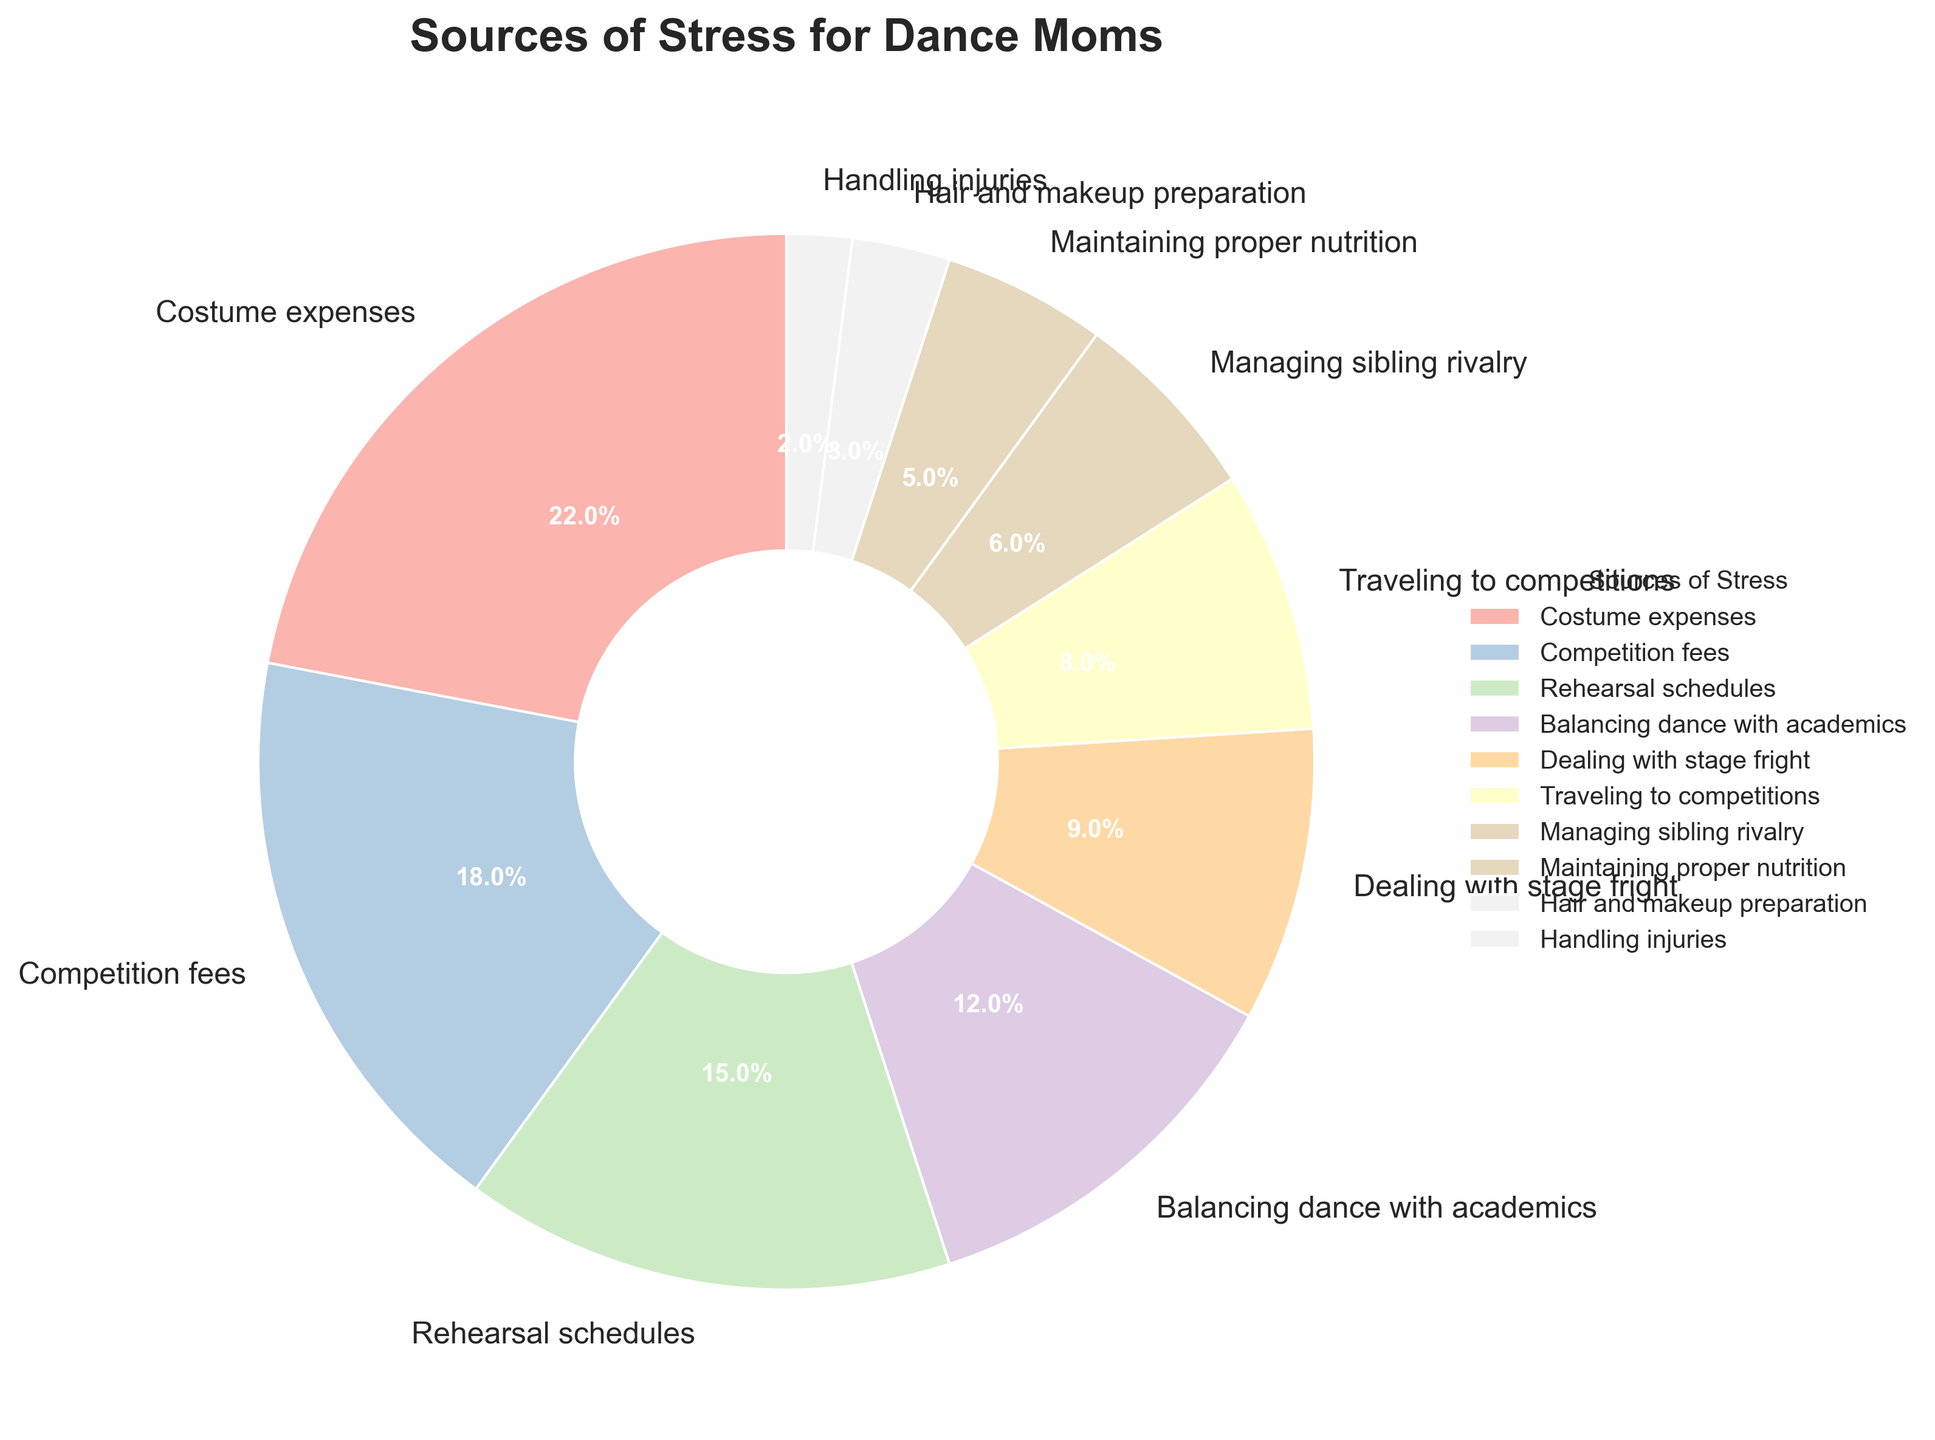Which source of stress has the highest percentage? To identify the source of stress with the highest percentage, look at the segment with the largest size in the pie chart. The segment labeled 'Costume expenses' has the largest portion.
Answer: Costume expenses How much more stressful, in terms of percentage, are costume expenses than managing sibling rivalry? The percentage for costume expenses is 22%, and for managing sibling rivalry, it is 6%. Subtract 6 from 22 to get the difference.
Answer: 16% What is the combined percentage of costume expenses and competition fees? Add the percentages for costume expenses (22%) and competition fees (18%).
Answer: 40% Which source of stress is the least significant? Identify the smallest segment in the pie chart, which is the segment labeled 'Handling injuries'.
Answer: Handling injuries Is balancing dance with academics more stressful than dealing with stage fright? Compare the percentages for balancing dance with academics (12%) and dealing with stage fright (9%). Since 12% is greater than 9%, balancing dance with academics is more stressful.
Answer: Yes What is the difference in percentage between rehearsal schedules and traveling to competitions? Subtract the percentage of traveling to competitions (8%) from the percentage of rehearsal schedules (15%).
Answer: 7% How do hair and makeup preparation and maintaining proper nutrition compare in terms of their percentages? Compare the percentages for hair and makeup preparation (3%) and maintaining proper nutrition (5%). Since 5% is greater than 3%, maintaining proper nutrition is more significant.
Answer: Hair and makeup preparation is less significant Which two sources of stress have a combined percentage of 18%? The two sources of stress that add up to 18% are competition fees (18%) on its own, fulfilling the requirement without any pairing needed.
Answer: Competition fees What is the average percentage of the sources of stress involving managing sibling rivalry, maintaining proper nutrition, and handling injuries? Add the percentages for managing sibling rivalry (6%), maintaining proper nutrition (5%), and handling injuries (2%), then divide by the number of sources (3). The sum is 13%, and the average is 13% / 3.
Answer: 4.33% 